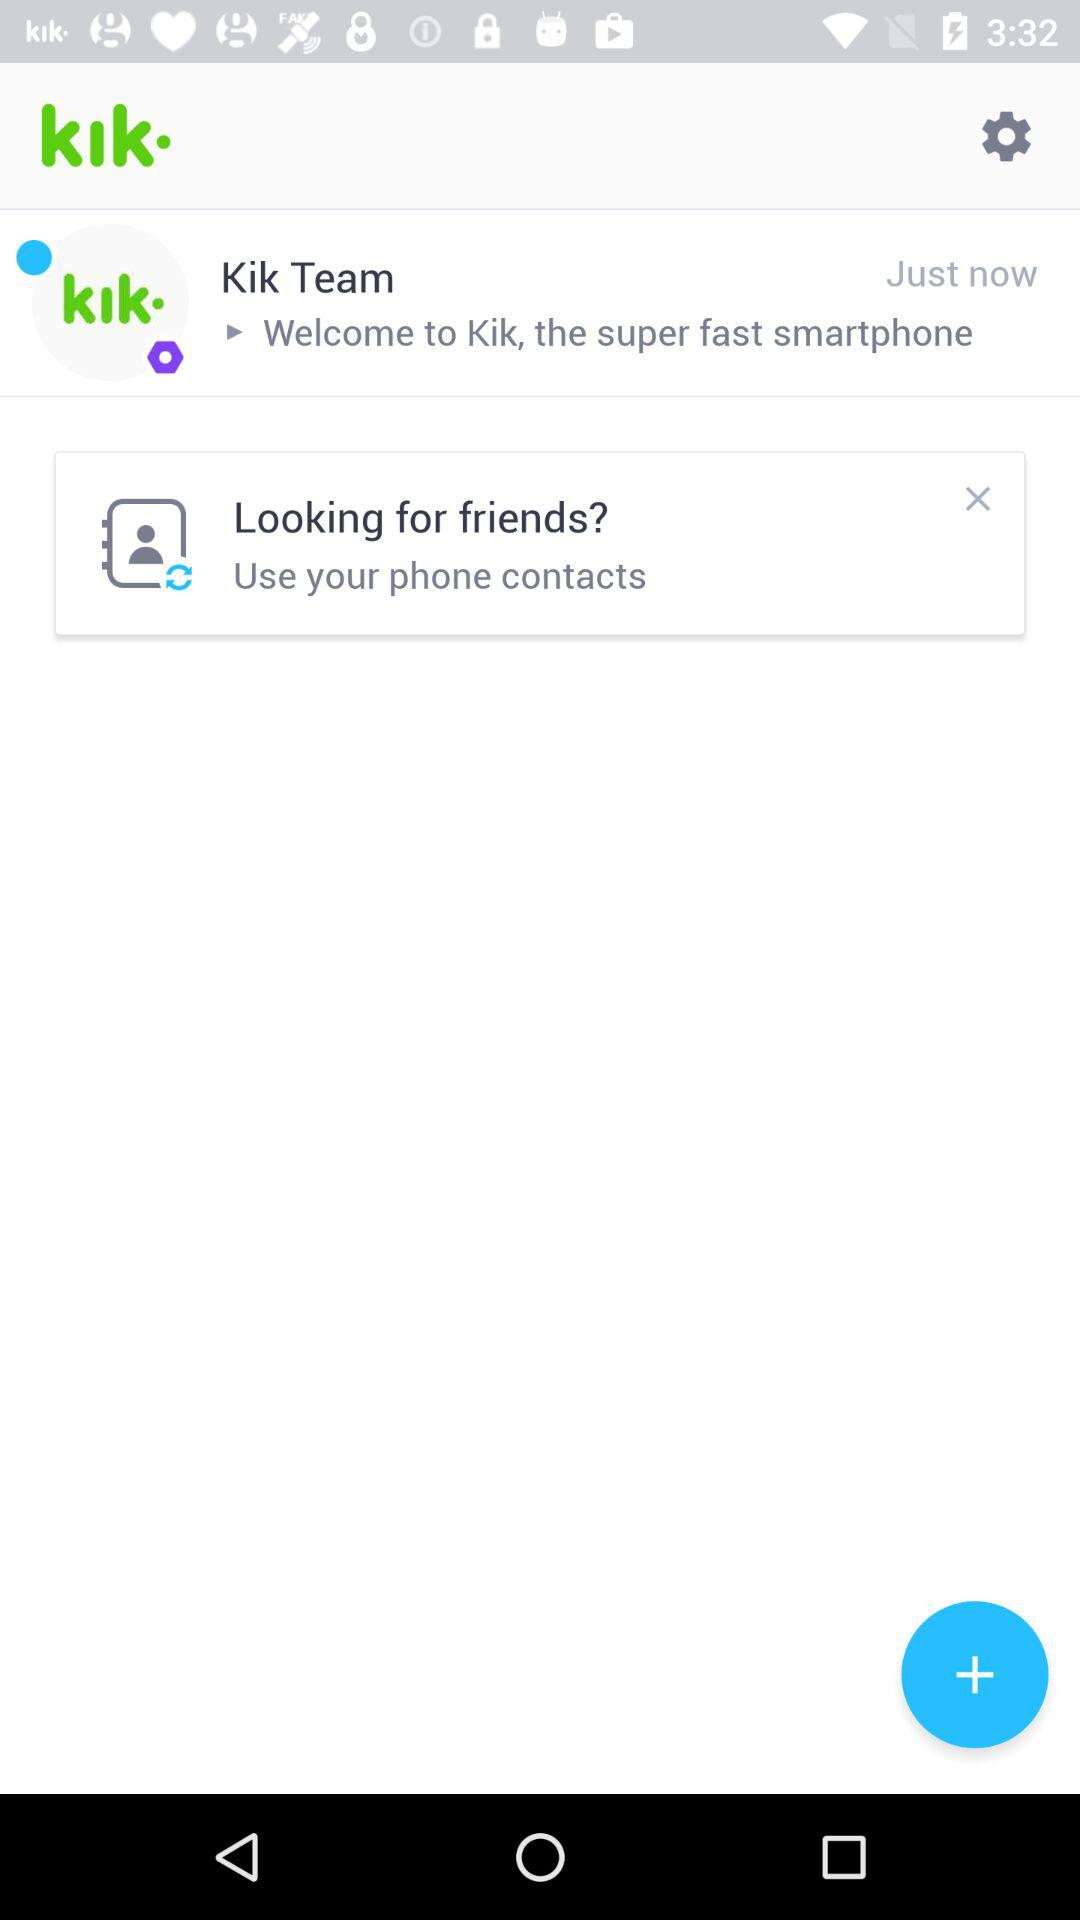What is the application name? The application name is "Kik". 